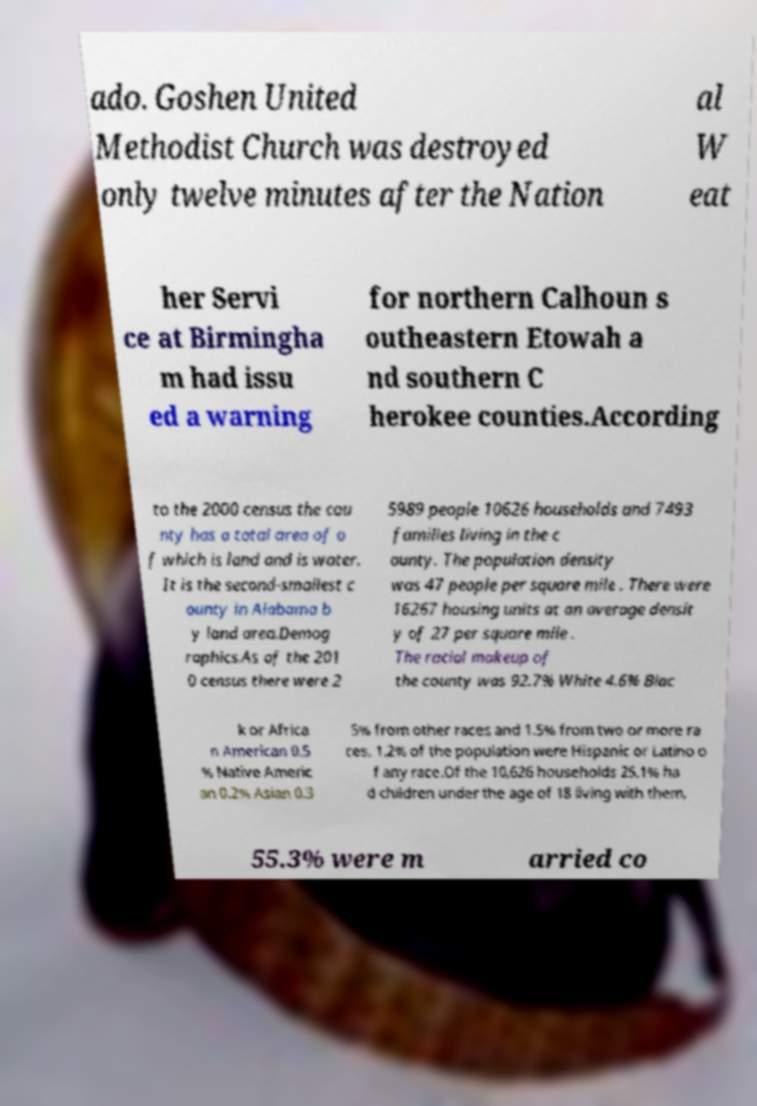For documentation purposes, I need the text within this image transcribed. Could you provide that? ado. Goshen United Methodist Church was destroyed only twelve minutes after the Nation al W eat her Servi ce at Birmingha m had issu ed a warning for northern Calhoun s outheastern Etowah a nd southern C herokee counties.According to the 2000 census the cou nty has a total area of o f which is land and is water. It is the second-smallest c ounty in Alabama b y land area.Demog raphics.As of the 201 0 census there were 2 5989 people 10626 households and 7493 families living in the c ounty. The population density was 47 people per square mile . There were 16267 housing units at an average densit y of 27 per square mile . The racial makeup of the county was 92.7% White 4.6% Blac k or Africa n American 0.5 % Native Americ an 0.2% Asian 0.3 5% from other races and 1.5% from two or more ra ces. 1.2% of the population were Hispanic or Latino o f any race.Of the 10,626 households 25.1% ha d children under the age of 18 living with them, 55.3% were m arried co 